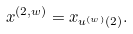Convert formula to latex. <formula><loc_0><loc_0><loc_500><loc_500>x ^ { ( 2 , w ) } = x _ { u ^ { ( w ) } ( 2 ) } .</formula> 